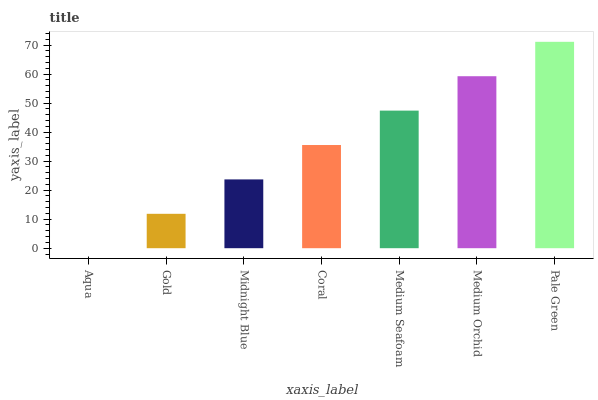Is Aqua the minimum?
Answer yes or no. Yes. Is Pale Green the maximum?
Answer yes or no. Yes. Is Gold the minimum?
Answer yes or no. No. Is Gold the maximum?
Answer yes or no. No. Is Gold greater than Aqua?
Answer yes or no. Yes. Is Aqua less than Gold?
Answer yes or no. Yes. Is Aqua greater than Gold?
Answer yes or no. No. Is Gold less than Aqua?
Answer yes or no. No. Is Coral the high median?
Answer yes or no. Yes. Is Coral the low median?
Answer yes or no. Yes. Is Pale Green the high median?
Answer yes or no. No. Is Midnight Blue the low median?
Answer yes or no. No. 